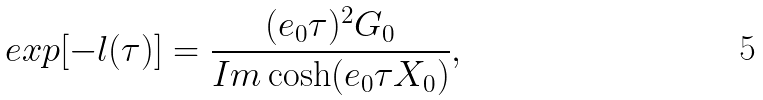<formula> <loc_0><loc_0><loc_500><loc_500>e x p [ - l ( \tau ) ] = \frac { ( e _ { 0 } \tau ) ^ { 2 } G _ { 0 } } { I m \cosh ( e _ { 0 } \tau X _ { 0 } ) } ,</formula> 